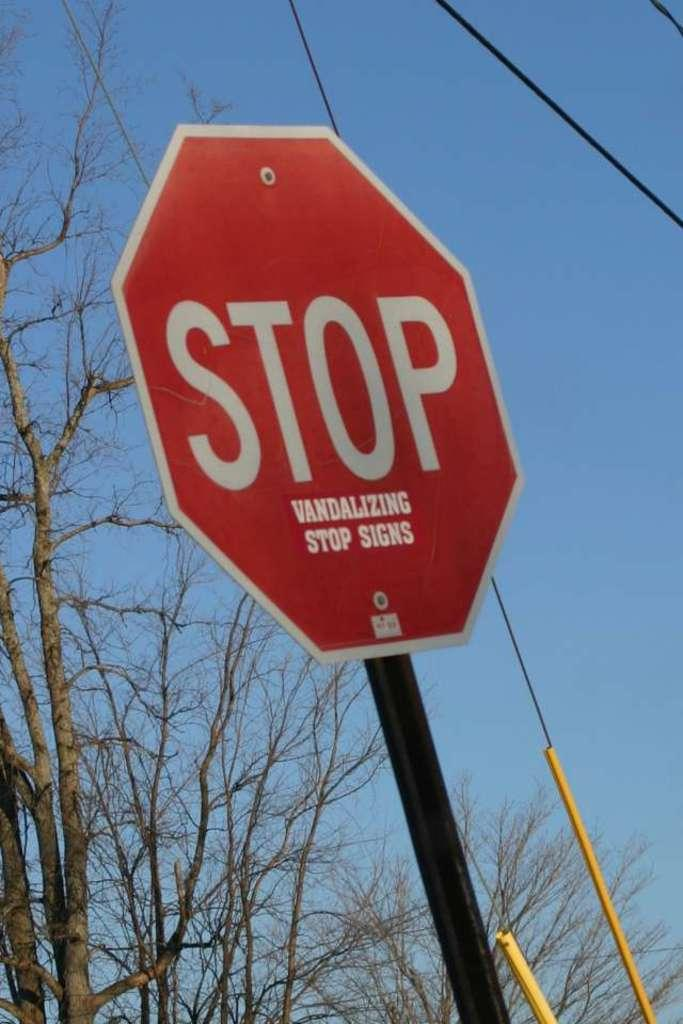<image>
Write a terse but informative summary of the picture. Octagon sign that reads STOP VANDALIZING STOP SIGNS 